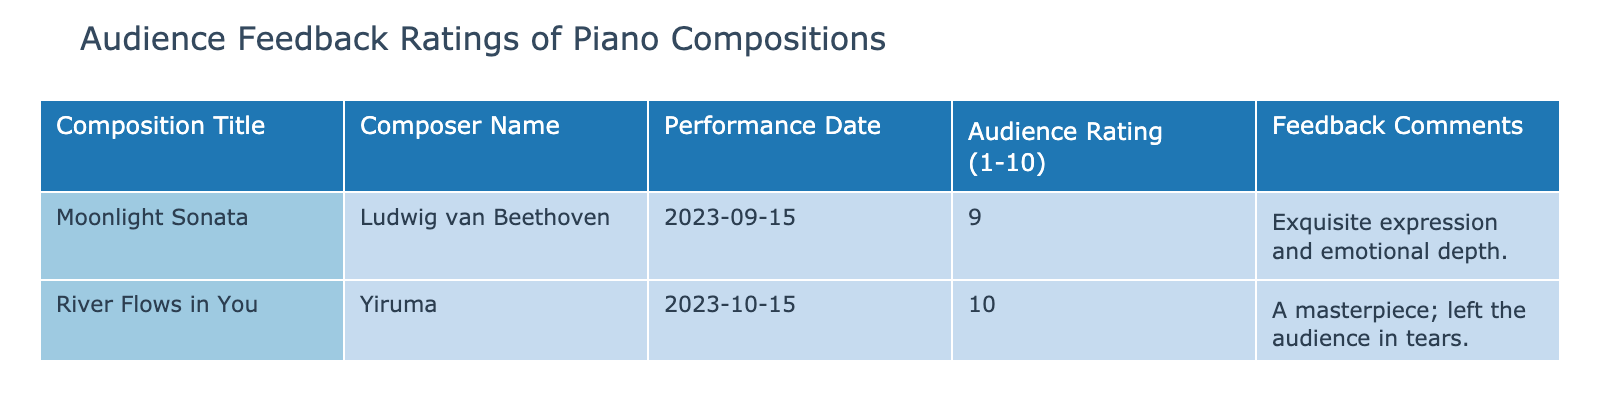What was the highest audience rating in the concert season? The highest rating listed in the table is 10, assigned to "River Flows in You" by Yiruma.
Answer: 10 Which composition received a feedback comment about leaving the audience in tears? The table indicates that "River Flows in You" received a comment stating it "left the audience in tears."
Answer: River Flows in You What is the average audience rating for the compositions listed? To find the average, we sum the ratings: 9 + 10 = 19. There are 2 compositions, so the average is 19/2 = 9.5.
Answer: 9.5 Is there any composition that received a rating of 8 or higher? Both compositions received ratings of 9 and 10, hence there are compositions with ratings of 8 or higher.
Answer: Yes Which composer had a composition with the highest rating, and what was that rating? "River Flows in You" by Yiruma had the highest rating of 10 according to the table.
Answer: Yiruma, 10 How many compositions in the table received a rating of 9 or higher? There are two compositions: "Moonlight Sonata" rated at 9 and "River Flows in You" rated at 10. Both are equal to or above 9.
Answer: 2 Was there any composition rated below 9? No, both compositions had ratings of 9 and 10; there are no ratings below 9 in the table.
Answer: No What is the difference between the highest and the lowest audience ratings? The highest rating is 10 (River Flows in You) and the lowest is 9 (Moonlight Sonata). Therefore, the difference is 10 - 9 = 1.
Answer: 1 What was the performance date of the composition that received the highest rating? The highest-rated composition, "River Flows in You," was performed on 2023-10-15.
Answer: 2023-10-15 